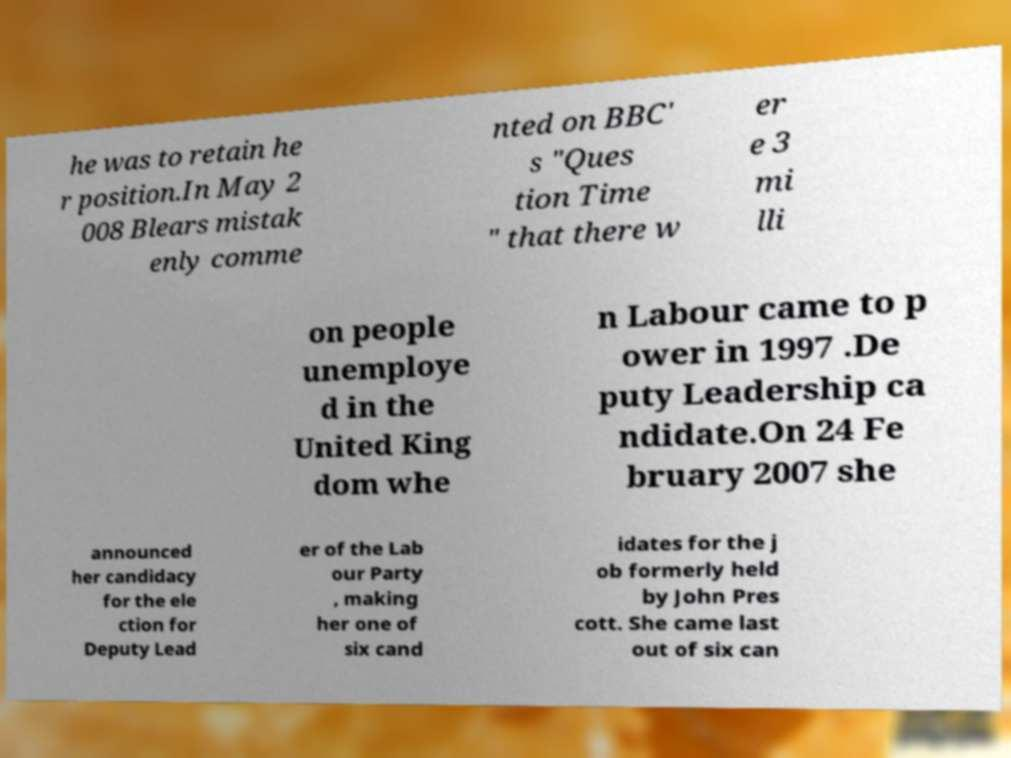There's text embedded in this image that I need extracted. Can you transcribe it verbatim? he was to retain he r position.In May 2 008 Blears mistak enly comme nted on BBC' s "Ques tion Time " that there w er e 3 mi lli on people unemploye d in the United King dom whe n Labour came to p ower in 1997 .De puty Leadership ca ndidate.On 24 Fe bruary 2007 she announced her candidacy for the ele ction for Deputy Lead er of the Lab our Party , making her one of six cand idates for the j ob formerly held by John Pres cott. She came last out of six can 